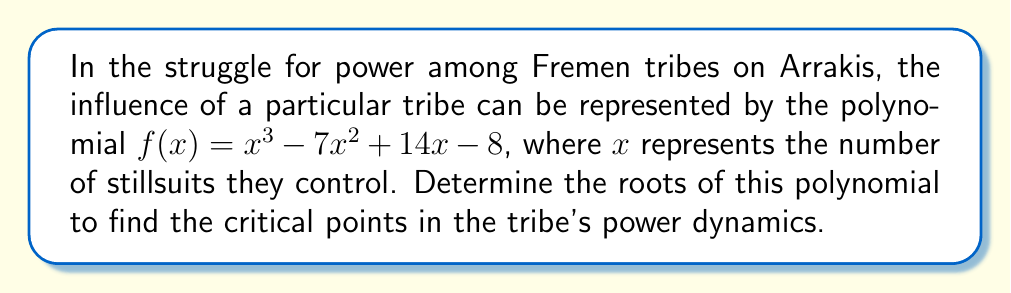Solve this math problem. To find the roots of the polynomial $f(x) = x^3 - 7x^2 + 14x - 8$, we need to factor it. Let's approach this step-by-step:

1) First, let's check if there's a rational root using the rational root theorem. The possible rational roots are the factors of the constant term (8): ±1, ±2, ±4, ±8.

2) Testing these values, we find that $f(1) = 0$. So, $(x-1)$ is a factor.

3) We can use polynomial long division to divide $f(x)$ by $(x-1)$:

   $x^3 - 7x^2 + 14x - 8 = (x-1)(x^2 - 6x + 8)$

4) Now we need to factor the quadratic $x^2 - 6x + 8$. We can use the quadratic formula or recognize it as a difference of squares:

   $x^2 - 6x + 8 = (x-2)(x-4)$

5) Therefore, the complete factorization is:

   $f(x) = (x-1)(x-2)(x-4)$

6) The roots of the polynomial are the values that make each factor equal to zero:

   $x-1 = 0$, $x-2 = 0$, $x-4 = 0$

   So, $x = 1$, $x = 2$, and $x = 4$

These roots represent the critical points in the tribe's power dynamics, corresponding to controlling 1, 2, or 4 stillsuits.
Answer: The roots of the polynomial are 1, 2, and 4. 